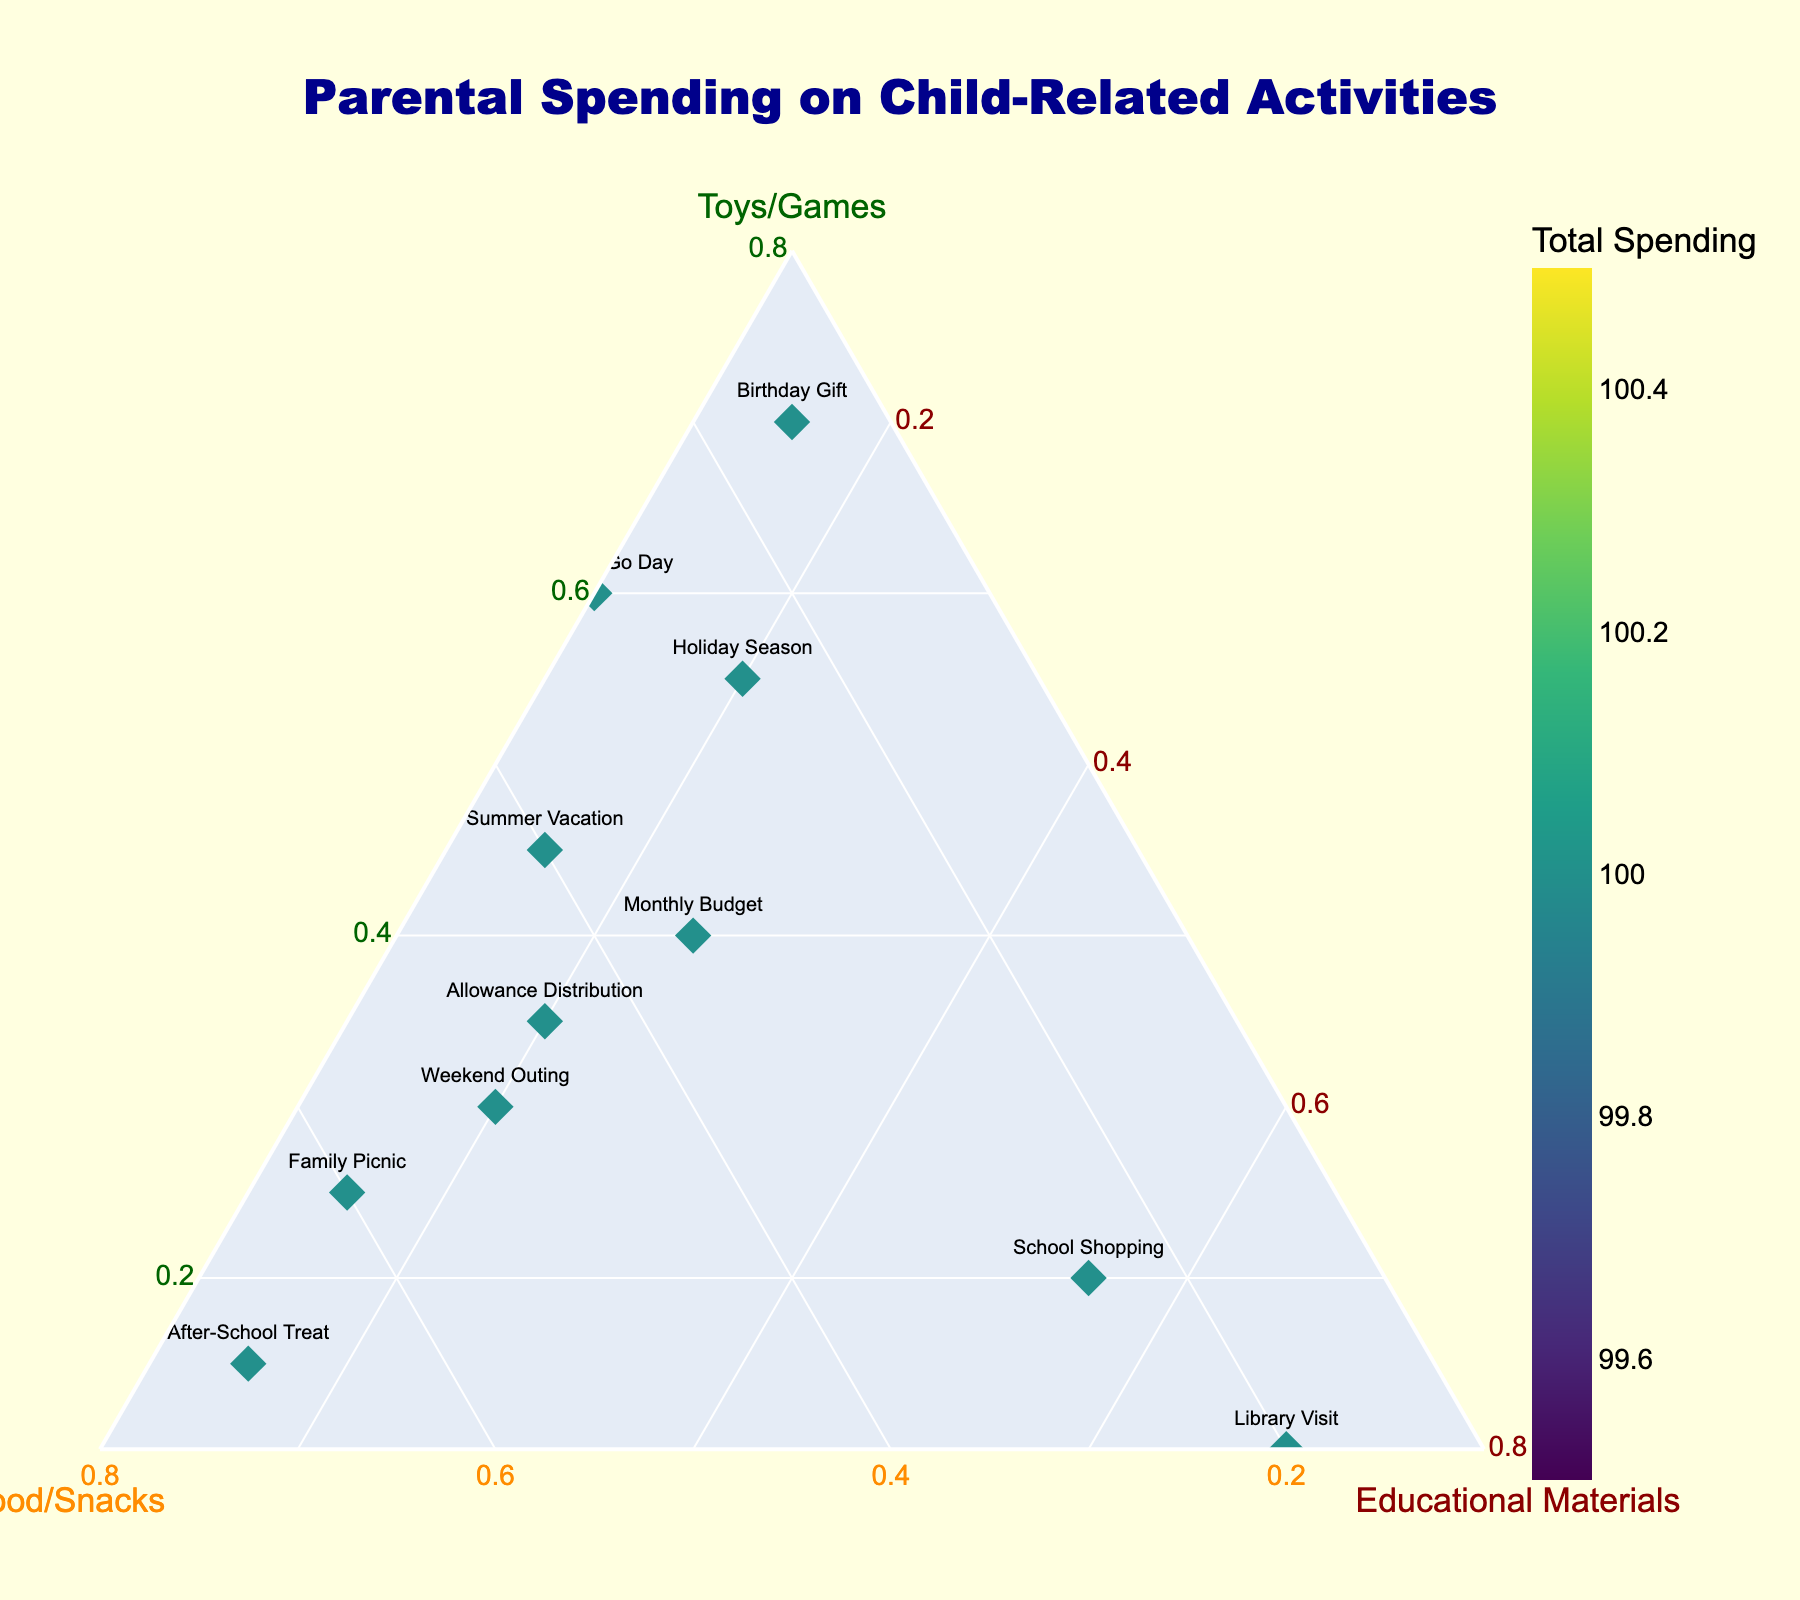What are the three categories plotted in the ternary plot? The three categories are the elements labelled on the axes of the ternary plot. They are "Toys/Games," "Food/Snacks," and "Educational Materials."
Answer: Toys/Games, Food/Snacks, Educational Materials Which activity allocates the highest percentage to "Toys/Games"? Find the point that is closest to the "Toys/Games" axis, indicating it has the highest proportion of spending in that category. The point labelled "Game Store Trip" is the closest.
Answer: Game Store Trip What is the total spending color scale indicating? The colorbar next to the plot indicates that the color of each point represents the total spending for that activity, with a specific color range shown in the legend.
Answer: Total spending How does the "Library Visit" breakdown compare between categories? Look at the point labelled "Library Visit" to see its position related to each axis. It lies closest to "Educational Materials," indicating a higher percentage in that category.
Answer: Highest in Educational Materials Which category dominates the "After-School Treat"? Look at the location of the "After-School Treat" point. It lies deepest into the "Food/Snacks" axis, indicating "Food/Snacks" dominates.
Answer: Food/Snacks What activity has the closest balance between all three categories? Find the point nearest to the center of the ternary plot, indicating equal allocation. The "Monthly Budget" point seems the most balanced.
Answer: Monthly Budget Which two activities have the highest total spendings as shown by the colors? Observe the color intensity of all points and locate the two with the darkest shades in the colorbar scale. They are "Summer Vacation" and "Birthday Gift."
Answer: Summer Vacation, Birthday Gift What is the total spending pattern on "Summer Vacation"? Locate "Summer Vacation" point and note its corresponding total spending color as well as relative positions on each axis. It indicates moderate amounts in "Toys/Games" and "Food/Snacks," and low in "Educational Materials."
Answer: Moderate Toys/Games, Food/Snacks; Low Educational Materials Which activities allocate the least to "Educational Materials"? Find the points that are furthest from the "Educational Materials" axis. "Game Store Trip" and "Pokemon Go Day" allocate the least.
Answer: Game Store Trip, Pokemon Go Day Is there any activity where "Educational Materials" constitute more than half of the spending? Locate any points lying on or beyond the halfway mark on the "Educational Materials" axis. "Library Visit" has the highest percentage over half.
Answer: Library Visit 